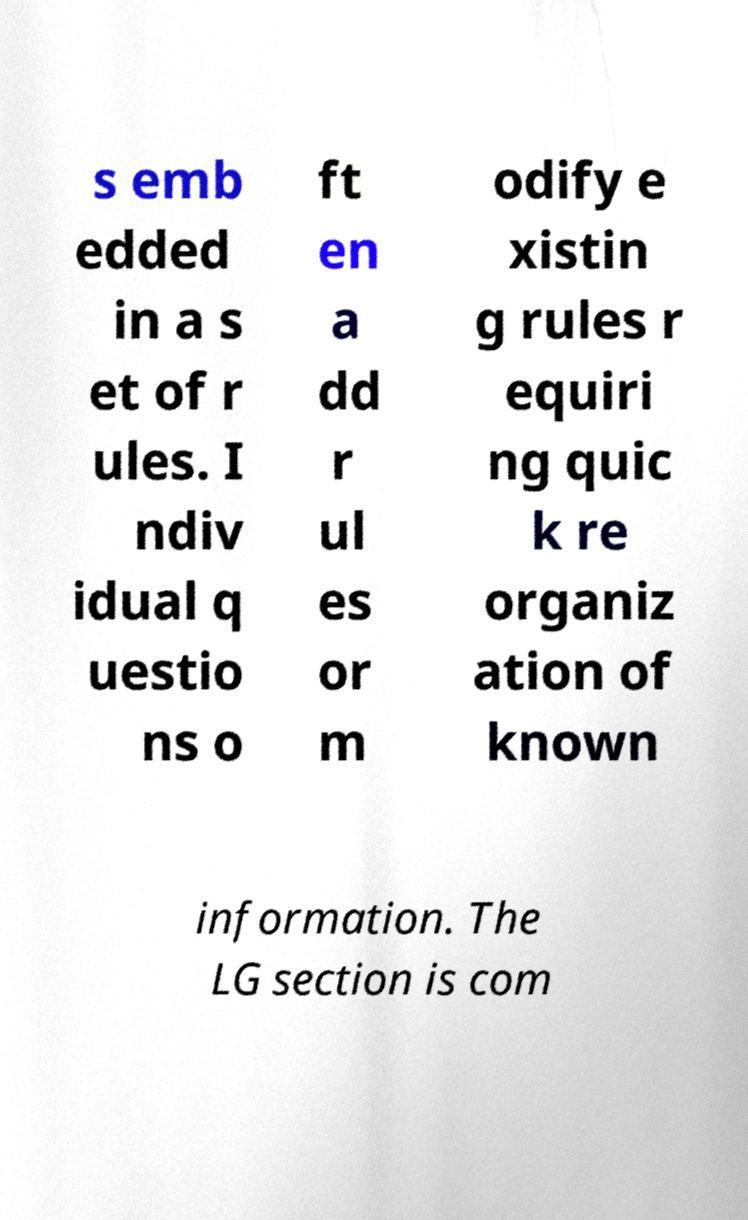There's text embedded in this image that I need extracted. Can you transcribe it verbatim? s emb edded in a s et of r ules. I ndiv idual q uestio ns o ft en a dd r ul es or m odify e xistin g rules r equiri ng quic k re organiz ation of known information. The LG section is com 